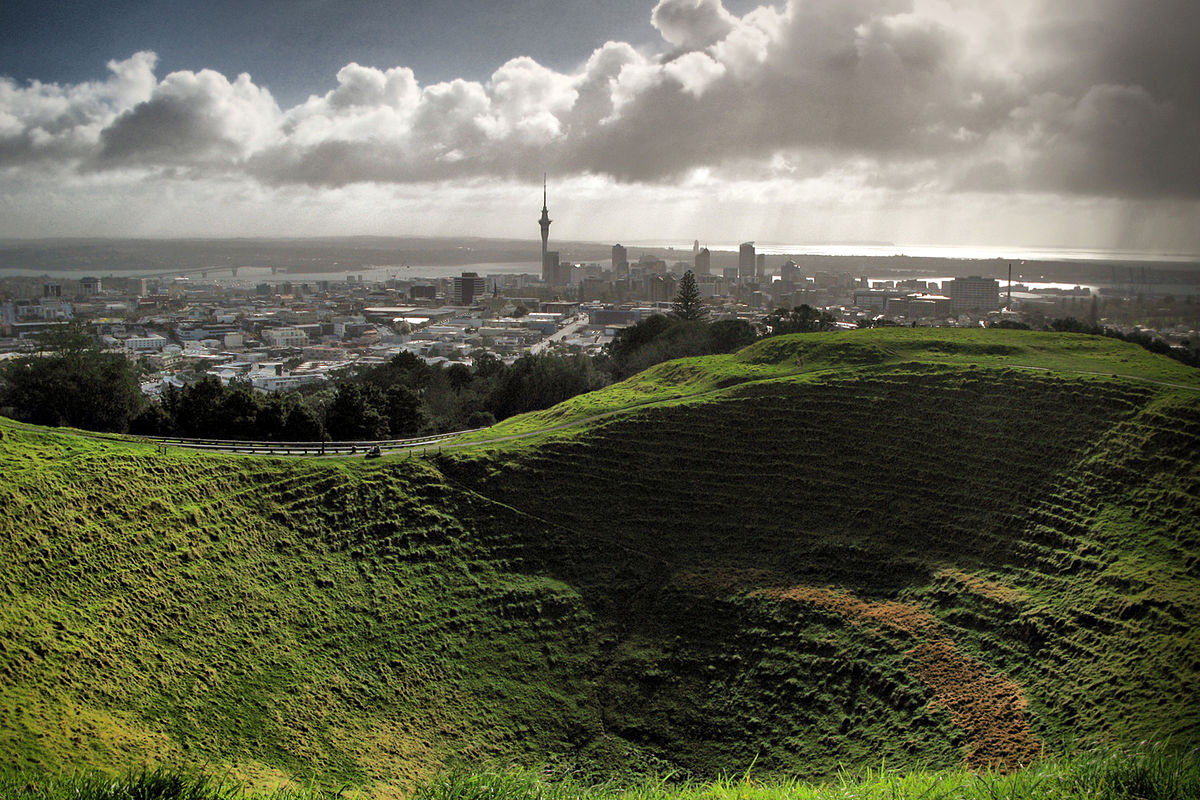What role does this location play for local wildlife? Mt Eden Crater serves as an important habitat for local wildlife, offering a unique ecosystem within an urban setting. The grassy and relatively undisturbed crater slopes provide shelter and food sources for various bird species and insects. Its preservation amidst the city helps maintain biodiversity, creating an urban oasis for wildlife and a natural reserve where city dwellers can observe native species in their habitat. 